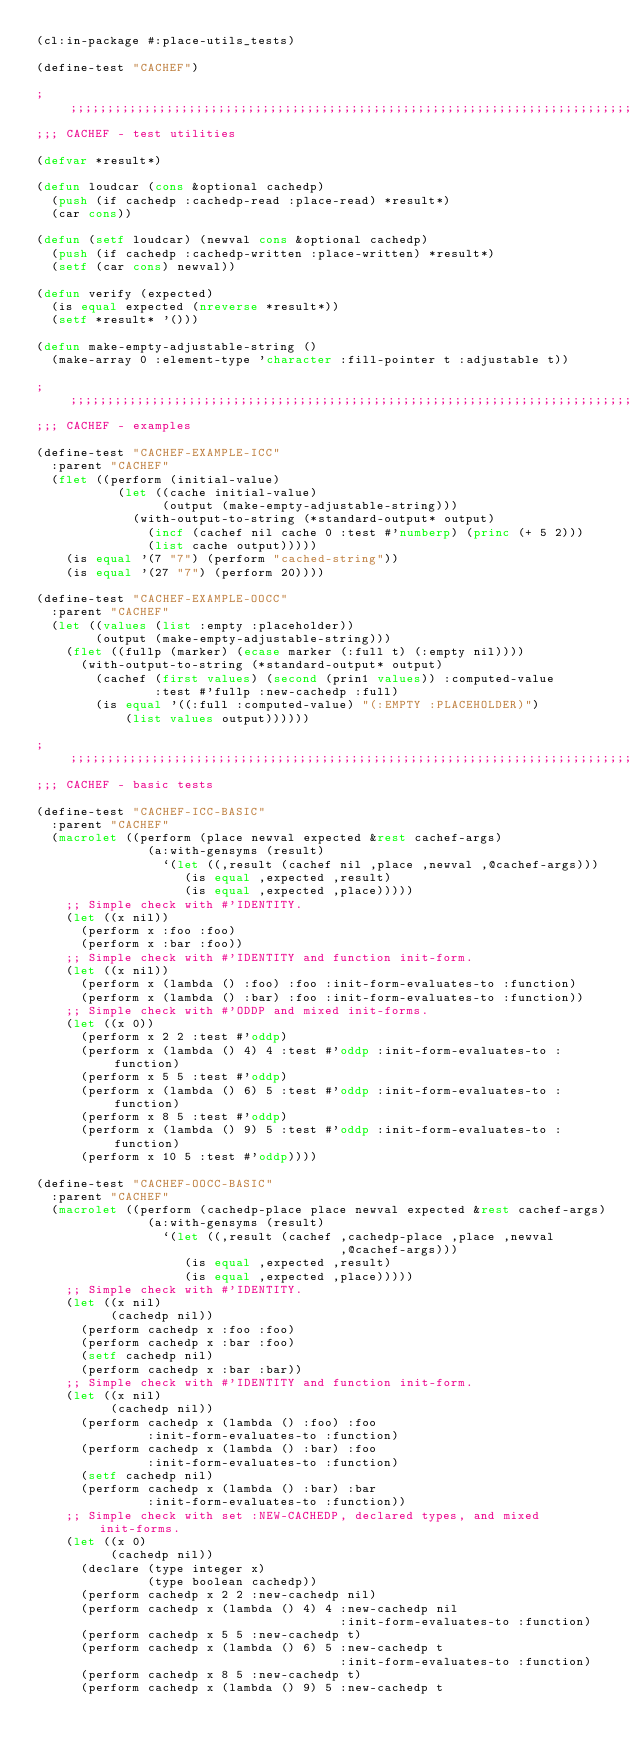<code> <loc_0><loc_0><loc_500><loc_500><_Lisp_>(cl:in-package #:place-utils_tests)

(define-test "CACHEF")

;;;;;;;;;;;;;;;;;;;;;;;;;;;;;;;;;;;;;;;;;;;;;;;;;;;;;;;;;;;;;;;;;;;;;;;;;;;;;;;;
;;; CACHEF - test utilities

(defvar *result*)

(defun loudcar (cons &optional cachedp)
  (push (if cachedp :cachedp-read :place-read) *result*)
  (car cons))

(defun (setf loudcar) (newval cons &optional cachedp)
  (push (if cachedp :cachedp-written :place-written) *result*)
  (setf (car cons) newval))

(defun verify (expected)
  (is equal expected (nreverse *result*))
  (setf *result* '()))

(defun make-empty-adjustable-string ()
  (make-array 0 :element-type 'character :fill-pointer t :adjustable t))

;;;;;;;;;;;;;;;;;;;;;;;;;;;;;;;;;;;;;;;;;;;;;;;;;;;;;;;;;;;;;;;;;;;;;;;;;;;;;;;;
;;; CACHEF - examples

(define-test "CACHEF-EXAMPLE-ICC"
  :parent "CACHEF"
  (flet ((perform (initial-value)
           (let ((cache initial-value)
                 (output (make-empty-adjustable-string)))
             (with-output-to-string (*standard-output* output)
               (incf (cachef nil cache 0 :test #'numberp) (princ (+ 5 2)))
               (list cache output)))))
    (is equal '(7 "7") (perform "cached-string"))
    (is equal '(27 "7") (perform 20))))

(define-test "CACHEF-EXAMPLE-OOCC"
  :parent "CACHEF"
  (let ((values (list :empty :placeholder))
        (output (make-empty-adjustable-string)))
    (flet ((fullp (marker) (ecase marker (:full t) (:empty nil))))
      (with-output-to-string (*standard-output* output)
        (cachef (first values) (second (prin1 values)) :computed-value
                :test #'fullp :new-cachedp :full)
        (is equal '((:full :computed-value) "(:EMPTY :PLACEHOLDER)")
            (list values output))))))

;;;;;;;;;;;;;;;;;;;;;;;;;;;;;;;;;;;;;;;;;;;;;;;;;;;;;;;;;;;;;;;;;;;;;;;;;;;;;;;;
;;; CACHEF - basic tests

(define-test "CACHEF-ICC-BASIC"
  :parent "CACHEF"
  (macrolet ((perform (place newval expected &rest cachef-args)
               (a:with-gensyms (result)
                 `(let ((,result (cachef nil ,place ,newval ,@cachef-args)))
                    (is equal ,expected ,result)
                    (is equal ,expected ,place)))))
    ;; Simple check with #'IDENTITY.
    (let ((x nil))
      (perform x :foo :foo)
      (perform x :bar :foo))
    ;; Simple check with #'IDENTITY and function init-form.
    (let ((x nil))
      (perform x (lambda () :foo) :foo :init-form-evaluates-to :function)
      (perform x (lambda () :bar) :foo :init-form-evaluates-to :function))
    ;; Simple check with #'ODDP and mixed init-forms.
    (let ((x 0))
      (perform x 2 2 :test #'oddp)
      (perform x (lambda () 4) 4 :test #'oddp :init-form-evaluates-to :function)
      (perform x 5 5 :test #'oddp)
      (perform x (lambda () 6) 5 :test #'oddp :init-form-evaluates-to :function)
      (perform x 8 5 :test #'oddp)
      (perform x (lambda () 9) 5 :test #'oddp :init-form-evaluates-to :function)
      (perform x 10 5 :test #'oddp))))

(define-test "CACHEF-OOCC-BASIC"
  :parent "CACHEF"
  (macrolet ((perform (cachedp-place place newval expected &rest cachef-args)
               (a:with-gensyms (result)
                 `(let ((,result (cachef ,cachedp-place ,place ,newval
                                         ,@cachef-args)))
                    (is equal ,expected ,result)
                    (is equal ,expected ,place)))))
    ;; Simple check with #'IDENTITY.
    (let ((x nil)
          (cachedp nil))
      (perform cachedp x :foo :foo)
      (perform cachedp x :bar :foo)
      (setf cachedp nil)
      (perform cachedp x :bar :bar))
    ;; Simple check with #'IDENTITY and function init-form.
    (let ((x nil)
          (cachedp nil))
      (perform cachedp x (lambda () :foo) :foo
               :init-form-evaluates-to :function)
      (perform cachedp x (lambda () :bar) :foo
               :init-form-evaluates-to :function)
      (setf cachedp nil)
      (perform cachedp x (lambda () :bar) :bar
               :init-form-evaluates-to :function))
    ;; Simple check with set :NEW-CACHEDP, declared types, and mixed init-forms.
    (let ((x 0)
          (cachedp nil))
      (declare (type integer x)
               (type boolean cachedp))
      (perform cachedp x 2 2 :new-cachedp nil)
      (perform cachedp x (lambda () 4) 4 :new-cachedp nil
                                         :init-form-evaluates-to :function)
      (perform cachedp x 5 5 :new-cachedp t)
      (perform cachedp x (lambda () 6) 5 :new-cachedp t
                                         :init-form-evaluates-to :function)
      (perform cachedp x 8 5 :new-cachedp t)
      (perform cachedp x (lambda () 9) 5 :new-cachedp t</code> 